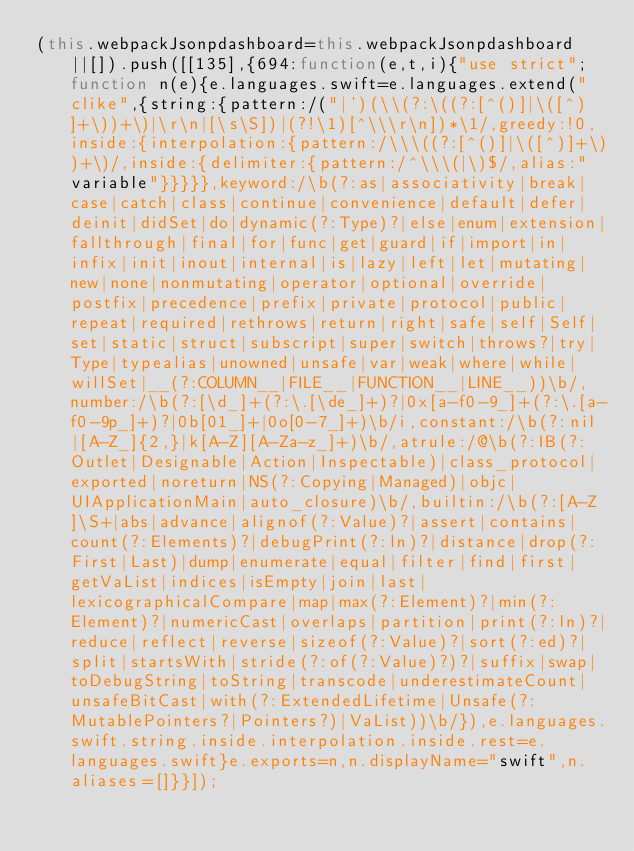<code> <loc_0><loc_0><loc_500><loc_500><_JavaScript_>(this.webpackJsonpdashboard=this.webpackJsonpdashboard||[]).push([[135],{694:function(e,t,i){"use strict";function n(e){e.languages.swift=e.languages.extend("clike",{string:{pattern:/("|')(\\(?:\((?:[^()]|\([^)]+\))+\)|\r\n|[\s\S])|(?!\1)[^\\\r\n])*\1/,greedy:!0,inside:{interpolation:{pattern:/\\\((?:[^()]|\([^)]+\))+\)/,inside:{delimiter:{pattern:/^\\\(|\)$/,alias:"variable"}}}}},keyword:/\b(?:as|associativity|break|case|catch|class|continue|convenience|default|defer|deinit|didSet|do|dynamic(?:Type)?|else|enum|extension|fallthrough|final|for|func|get|guard|if|import|in|infix|init|inout|internal|is|lazy|left|let|mutating|new|none|nonmutating|operator|optional|override|postfix|precedence|prefix|private|protocol|public|repeat|required|rethrows|return|right|safe|self|Self|set|static|struct|subscript|super|switch|throws?|try|Type|typealias|unowned|unsafe|var|weak|where|while|willSet|__(?:COLUMN__|FILE__|FUNCTION__|LINE__))\b/,number:/\b(?:[\d_]+(?:\.[\de_]+)?|0x[a-f0-9_]+(?:\.[a-f0-9p_]+)?|0b[01_]+|0o[0-7_]+)\b/i,constant:/\b(?:nil|[A-Z_]{2,}|k[A-Z][A-Za-z_]+)\b/,atrule:/@\b(?:IB(?:Outlet|Designable|Action|Inspectable)|class_protocol|exported|noreturn|NS(?:Copying|Managed)|objc|UIApplicationMain|auto_closure)\b/,builtin:/\b(?:[A-Z]\S+|abs|advance|alignof(?:Value)?|assert|contains|count(?:Elements)?|debugPrint(?:ln)?|distance|drop(?:First|Last)|dump|enumerate|equal|filter|find|first|getVaList|indices|isEmpty|join|last|lexicographicalCompare|map|max(?:Element)?|min(?:Element)?|numericCast|overlaps|partition|print(?:ln)?|reduce|reflect|reverse|sizeof(?:Value)?|sort(?:ed)?|split|startsWith|stride(?:of(?:Value)?)?|suffix|swap|toDebugString|toString|transcode|underestimateCount|unsafeBitCast|with(?:ExtendedLifetime|Unsafe(?:MutablePointers?|Pointers?)|VaList))\b/}),e.languages.swift.string.inside.interpolation.inside.rest=e.languages.swift}e.exports=n,n.displayName="swift",n.aliases=[]}}]);</code> 